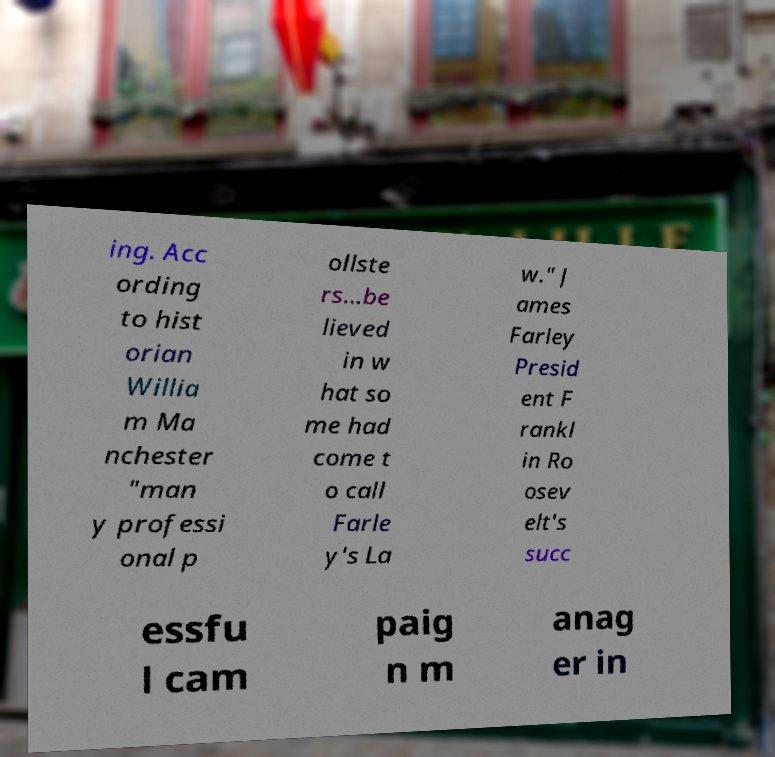Could you assist in decoding the text presented in this image and type it out clearly? ing. Acc ording to hist orian Willia m Ma nchester "man y professi onal p ollste rs...be lieved in w hat so me had come t o call Farle y's La w." J ames Farley Presid ent F rankl in Ro osev elt's succ essfu l cam paig n m anag er in 